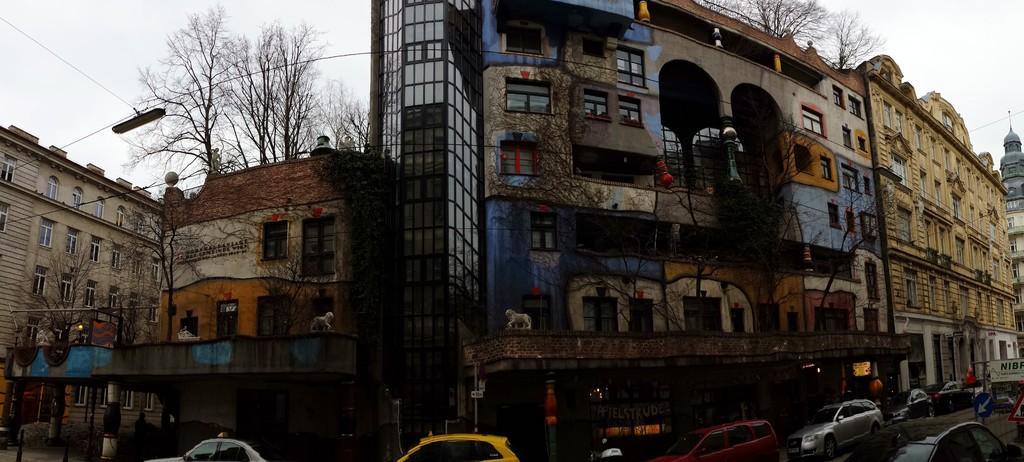How would you summarize this image in a sentence or two? Here there are buildings with the windows, here there are trees, this is sky, here there are cars on the road. 